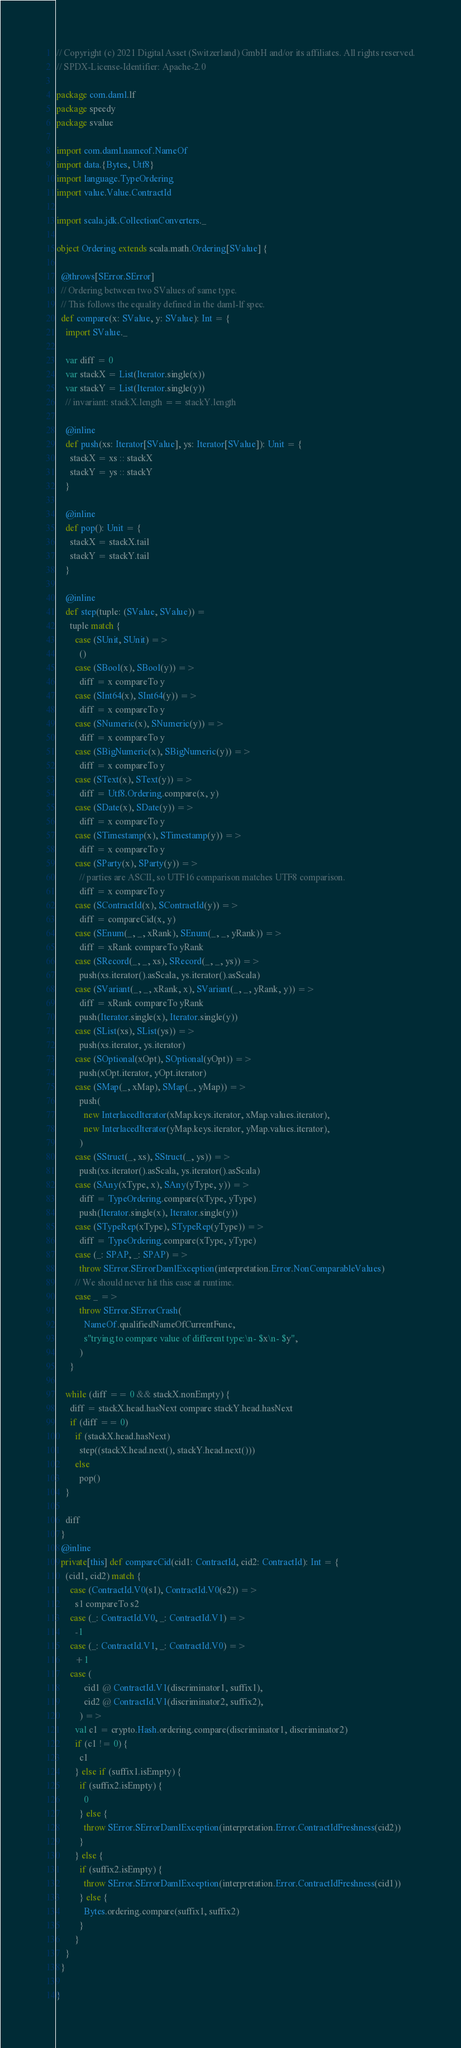<code> <loc_0><loc_0><loc_500><loc_500><_Scala_>// Copyright (c) 2021 Digital Asset (Switzerland) GmbH and/or its affiliates. All rights reserved.
// SPDX-License-Identifier: Apache-2.0

package com.daml.lf
package speedy
package svalue

import com.daml.nameof.NameOf
import data.{Bytes, Utf8}
import language.TypeOrdering
import value.Value.ContractId

import scala.jdk.CollectionConverters._

object Ordering extends scala.math.Ordering[SValue] {

  @throws[SError.SError]
  // Ordering between two SValues of same type.
  // This follows the equality defined in the daml-lf spec.
  def compare(x: SValue, y: SValue): Int = {
    import SValue._

    var diff = 0
    var stackX = List(Iterator.single(x))
    var stackY = List(Iterator.single(y))
    // invariant: stackX.length == stackY.length

    @inline
    def push(xs: Iterator[SValue], ys: Iterator[SValue]): Unit = {
      stackX = xs :: stackX
      stackY = ys :: stackY
    }

    @inline
    def pop(): Unit = {
      stackX = stackX.tail
      stackY = stackY.tail
    }

    @inline
    def step(tuple: (SValue, SValue)) =
      tuple match {
        case (SUnit, SUnit) =>
          ()
        case (SBool(x), SBool(y)) =>
          diff = x compareTo y
        case (SInt64(x), SInt64(y)) =>
          diff = x compareTo y
        case (SNumeric(x), SNumeric(y)) =>
          diff = x compareTo y
        case (SBigNumeric(x), SBigNumeric(y)) =>
          diff = x compareTo y
        case (SText(x), SText(y)) =>
          diff = Utf8.Ordering.compare(x, y)
        case (SDate(x), SDate(y)) =>
          diff = x compareTo y
        case (STimestamp(x), STimestamp(y)) =>
          diff = x compareTo y
        case (SParty(x), SParty(y)) =>
          // parties are ASCII, so UTF16 comparison matches UTF8 comparison.
          diff = x compareTo y
        case (SContractId(x), SContractId(y)) =>
          diff = compareCid(x, y)
        case (SEnum(_, _, xRank), SEnum(_, _, yRank)) =>
          diff = xRank compareTo yRank
        case (SRecord(_, _, xs), SRecord(_, _, ys)) =>
          push(xs.iterator().asScala, ys.iterator().asScala)
        case (SVariant(_, _, xRank, x), SVariant(_, _, yRank, y)) =>
          diff = xRank compareTo yRank
          push(Iterator.single(x), Iterator.single(y))
        case (SList(xs), SList(ys)) =>
          push(xs.iterator, ys.iterator)
        case (SOptional(xOpt), SOptional(yOpt)) =>
          push(xOpt.iterator, yOpt.iterator)
        case (SMap(_, xMap), SMap(_, yMap)) =>
          push(
            new InterlacedIterator(xMap.keys.iterator, xMap.values.iterator),
            new InterlacedIterator(yMap.keys.iterator, yMap.values.iterator),
          )
        case (SStruct(_, xs), SStruct(_, ys)) =>
          push(xs.iterator().asScala, ys.iterator().asScala)
        case (SAny(xType, x), SAny(yType, y)) =>
          diff = TypeOrdering.compare(xType, yType)
          push(Iterator.single(x), Iterator.single(y))
        case (STypeRep(xType), STypeRep(yType)) =>
          diff = TypeOrdering.compare(xType, yType)
        case (_: SPAP, _: SPAP) =>
          throw SError.SErrorDamlException(interpretation.Error.NonComparableValues)
        // We should never hit this case at runtime.
        case _ =>
          throw SError.SErrorCrash(
            NameOf.qualifiedNameOfCurrentFunc,
            s"trying to compare value of different type:\n- $x\n- $y",
          )
      }

    while (diff == 0 && stackX.nonEmpty) {
      diff = stackX.head.hasNext compare stackY.head.hasNext
      if (diff == 0)
        if (stackX.head.hasNext)
          step((stackX.head.next(), stackY.head.next()))
        else
          pop()
    }

    diff
  }
  @inline
  private[this] def compareCid(cid1: ContractId, cid2: ContractId): Int = {
    (cid1, cid2) match {
      case (ContractId.V0(s1), ContractId.V0(s2)) =>
        s1 compareTo s2
      case (_: ContractId.V0, _: ContractId.V1) =>
        -1
      case (_: ContractId.V1, _: ContractId.V0) =>
        +1
      case (
            cid1 @ ContractId.V1(discriminator1, suffix1),
            cid2 @ ContractId.V1(discriminator2, suffix2),
          ) =>
        val c1 = crypto.Hash.ordering.compare(discriminator1, discriminator2)
        if (c1 != 0) {
          c1
        } else if (suffix1.isEmpty) {
          if (suffix2.isEmpty) {
            0
          } else {
            throw SError.SErrorDamlException(interpretation.Error.ContractIdFreshness(cid2))
          }
        } else {
          if (suffix2.isEmpty) {
            throw SError.SErrorDamlException(interpretation.Error.ContractIdFreshness(cid1))
          } else {
            Bytes.ordering.compare(suffix1, suffix2)
          }
        }
    }
  }

}
</code> 